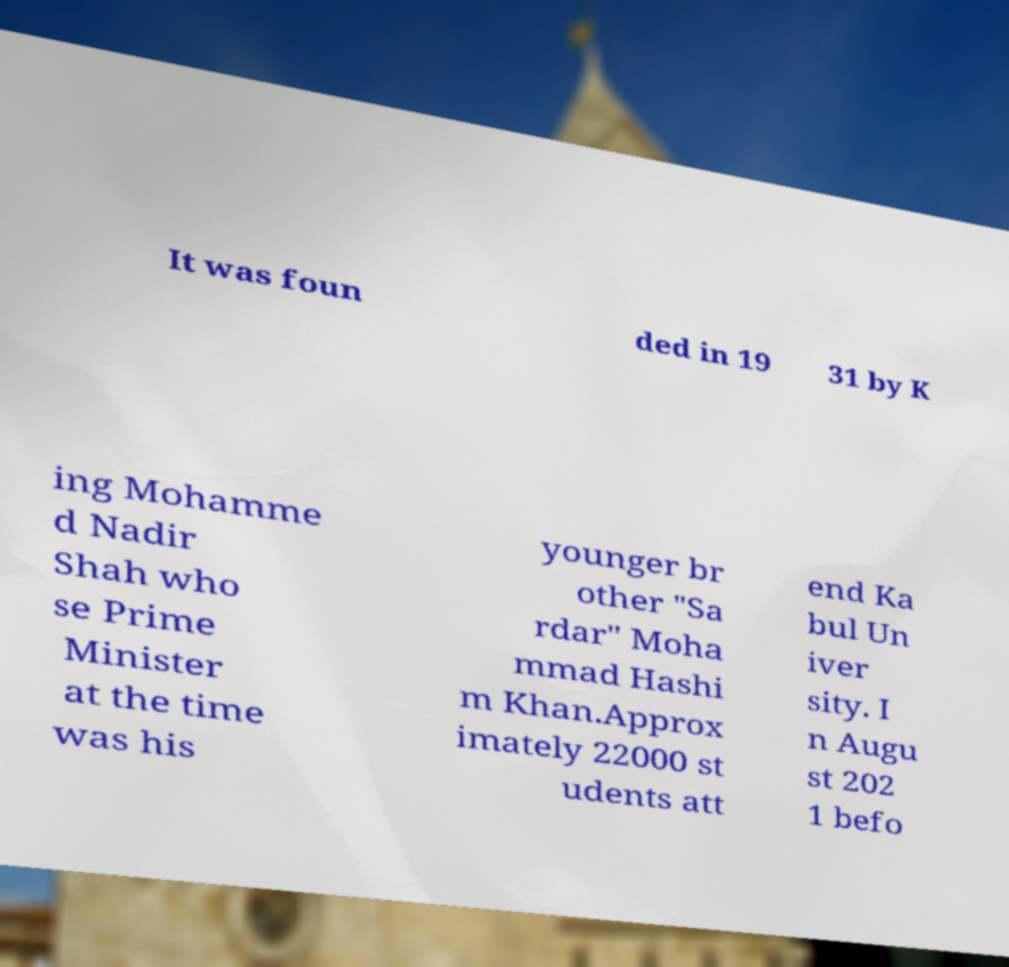Please read and relay the text visible in this image. What does it say? It was foun ded in 19 31 by K ing Mohamme d Nadir Shah who se Prime Minister at the time was his younger br other "Sa rdar" Moha mmad Hashi m Khan.Approx imately 22000 st udents att end Ka bul Un iver sity. I n Augu st 202 1 befo 